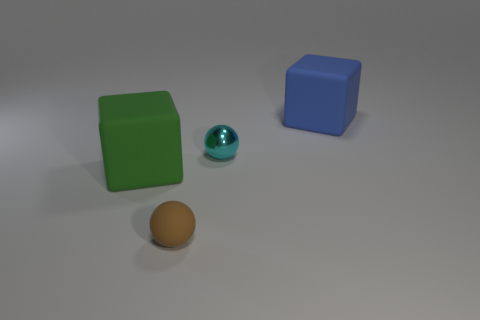Subtract 1 cubes. How many cubes are left? 1 Add 4 large matte cubes. How many large matte cubes are left? 6 Add 3 cyan metallic objects. How many cyan metallic objects exist? 4 Add 2 yellow metallic balls. How many objects exist? 6 Subtract all green blocks. How many blocks are left? 1 Subtract 0 purple blocks. How many objects are left? 4 Subtract all green blocks. Subtract all yellow cylinders. How many blocks are left? 1 Subtract all purple cubes. How many yellow spheres are left? 0 Subtract all large green cubes. Subtract all yellow metallic balls. How many objects are left? 3 